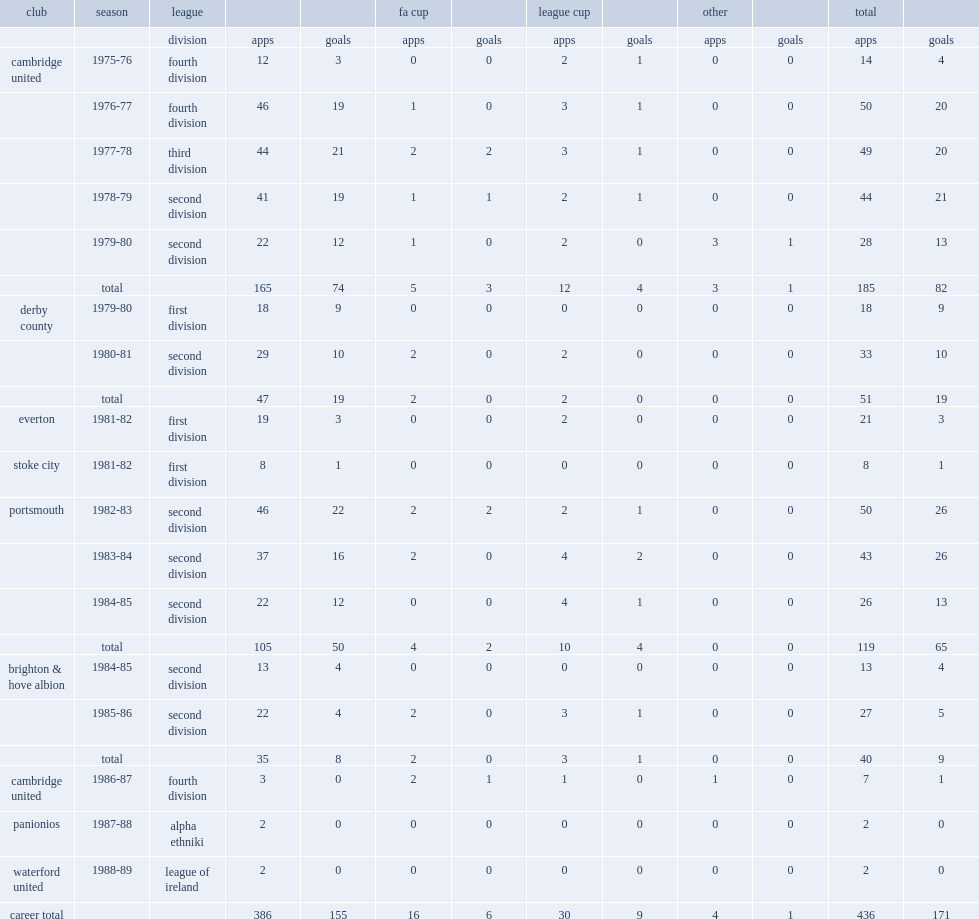How many goals did alan biley make with the cambridge club in total? 82.0. 